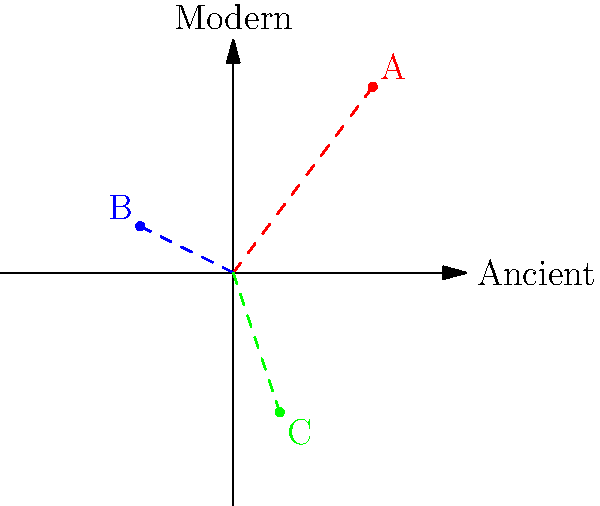In the given coordinate system, ancient agricultural land use patterns are represented on the x-axis, and modern patterns on the y-axis. Three points (A, B, and C) are plotted. Which point represents the most significant shift towards modern agricultural practices while retaining some ancient methods? To answer this question, we need to analyze the position of each point in relation to both axes:

1. Point A (3, 4):
   - Has a high positive x-value (3), indicating significant use of ancient methods.
   - Has a high positive y-value (4), indicating significant adoption of modern practices.

2. Point B (-2, 1):
   - Has a negative x-value (-2), indicating a move away from ancient methods.
   - Has a low positive y-value (1), indicating some adoption of modern practices.

3. Point C (1, -3):
   - Has a low positive x-value (1), indicating some retention of ancient methods.
   - Has a negative y-value (-3), indicating a rejection of modern practices.

The question asks for the point that represents the most significant shift towards modern agricultural practices while retaining some ancient methods. This means we're looking for a point with:
a) A high positive y-value (modern practices)
b) A positive x-value (retention of some ancient methods)

Point A (3, 4) best fits these criteria. It has the highest y-value, indicating the most significant adoption of modern practices, while its positive x-value shows that it still retains some ancient methods.

Point B has moved away from ancient methods entirely, and Point C has rejected modern practices, so neither of these fit the criteria as well as Point A.
Answer: A 